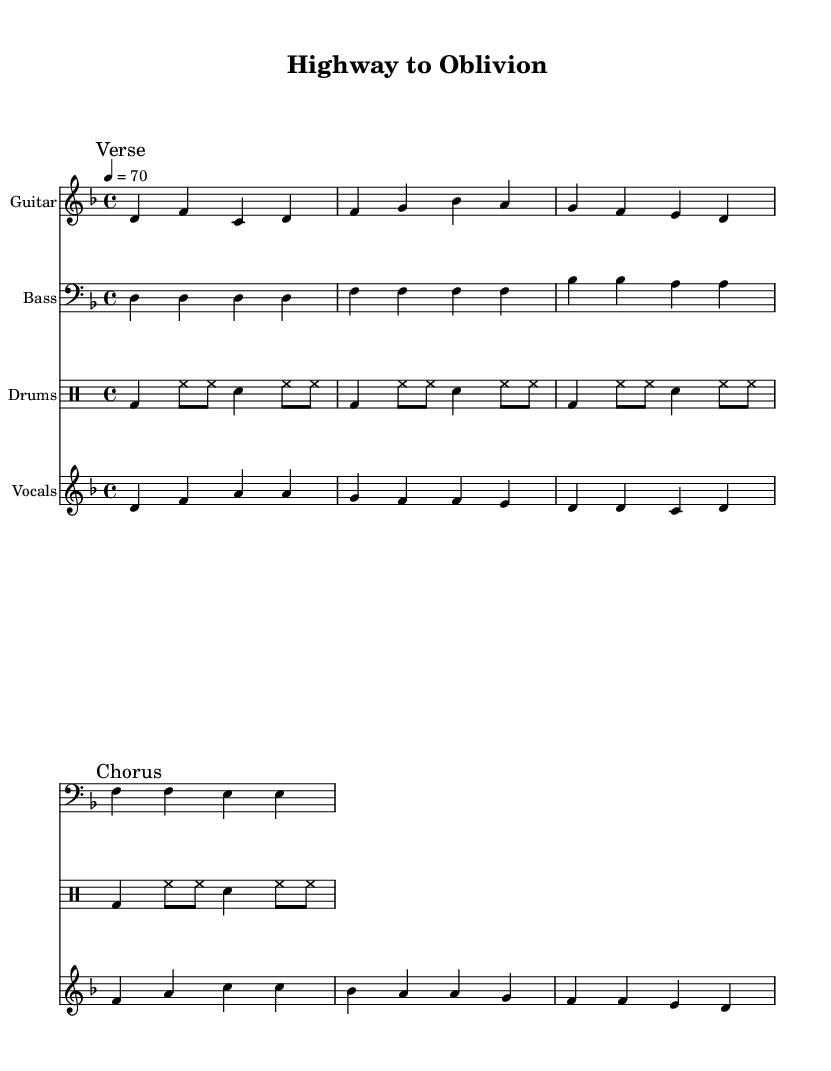What is the key signature of this music? The key signature is indicated at the beginning of the sheet music, showing two flats. The key of D minor has one flat (B flat), and since the music stays in the D minor tonality, it confirmed that D minor is the key.
Answer: D minor What is the time signature of this music? The time signature is shown after the key signature and is indicated by the numbers above and below. It shows a 4 above a 4, meaning there are four beats in each measure, and a quarter note gets one beat.
Answer: 4/4 What is the tempo marking of this music? The tempo is indicated in the header of the sheet music marked with "4 = 70", meaning there are 70 beats per minute. This tells how fast the music should be played.
Answer: 70 How many measures are in the guitar riff? By counting the segments in the guitar riff section, there are 4 measures as separated by vertical lines on the sheet. Each measure consists of four beats within the 4/4 time signature.
Answer: 4 measures What is the main theme reflected in the lyrics of the chorus? The chorus lyrics express a dark and intense theme reflecting fear and danger on the road, suggesting a sense of despair. The phrase "Highway to Oblivion" conveys this somber message.
Answer: Oblivion What type of instruments are being used in this composition? The sheet music specifies the instruments in separate staves: Guitar, Bass, Drums, and Vocals. Each one is uniquely represented, showing the typical components of a metal band.
Answer: Guitar, Bass, Drums, Vocals What musical genre does this piece belong to? The song's title, lyrical themes, and instrumentation prominently align with the characteristics of metal, specifically doom metal, which often incorporates heavier and darker elements.
Answer: Doom Metal 